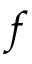<formula> <loc_0><loc_0><loc_500><loc_500>f</formula> 